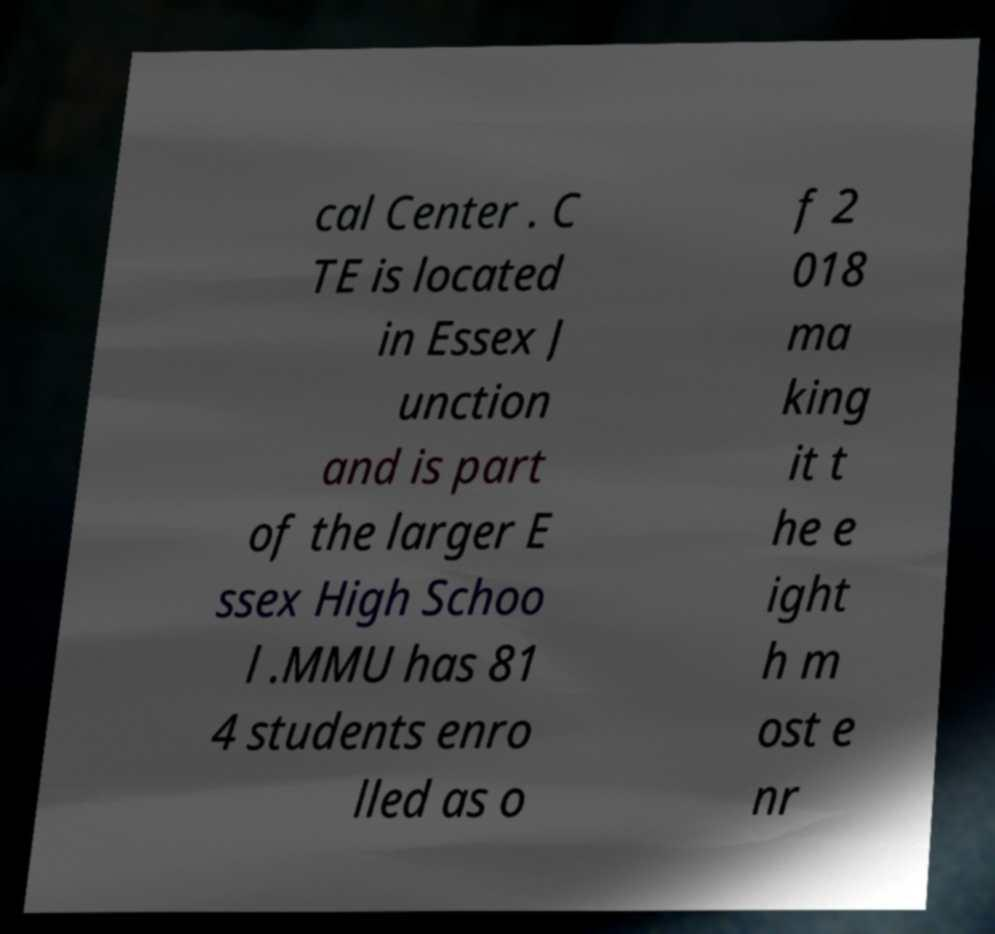Could you assist in decoding the text presented in this image and type it out clearly? cal Center . C TE is located in Essex J unction and is part of the larger E ssex High Schoo l .MMU has 81 4 students enro lled as o f 2 018 ma king it t he e ight h m ost e nr 